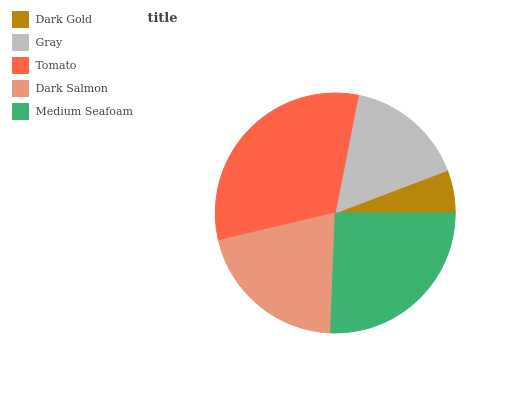Is Dark Gold the minimum?
Answer yes or no. Yes. Is Tomato the maximum?
Answer yes or no. Yes. Is Gray the minimum?
Answer yes or no. No. Is Gray the maximum?
Answer yes or no. No. Is Gray greater than Dark Gold?
Answer yes or no. Yes. Is Dark Gold less than Gray?
Answer yes or no. Yes. Is Dark Gold greater than Gray?
Answer yes or no. No. Is Gray less than Dark Gold?
Answer yes or no. No. Is Dark Salmon the high median?
Answer yes or no. Yes. Is Dark Salmon the low median?
Answer yes or no. Yes. Is Gray the high median?
Answer yes or no. No. Is Gray the low median?
Answer yes or no. No. 